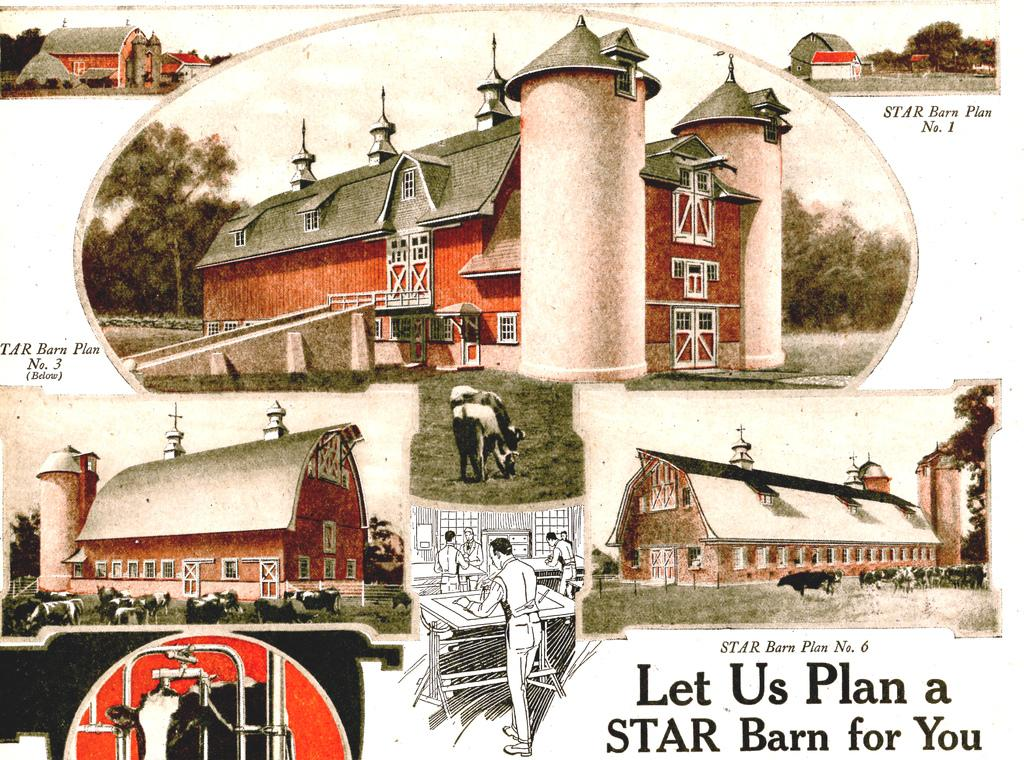What is featured on the poster in the image? The poster contains buildings and cows. Is there any text on the poster? Yes, there is text at the bottom of the poster. What else can be seen in the image besides the poster? Trees are visible in the image. What type of list can be seen on the poster? There is no list present on the poster; it contains buildings, cows, and text. What kind of cup is being used to serve lunch in the image? There is no cup or lunch depicted in the image; it only features a poster and trees. 